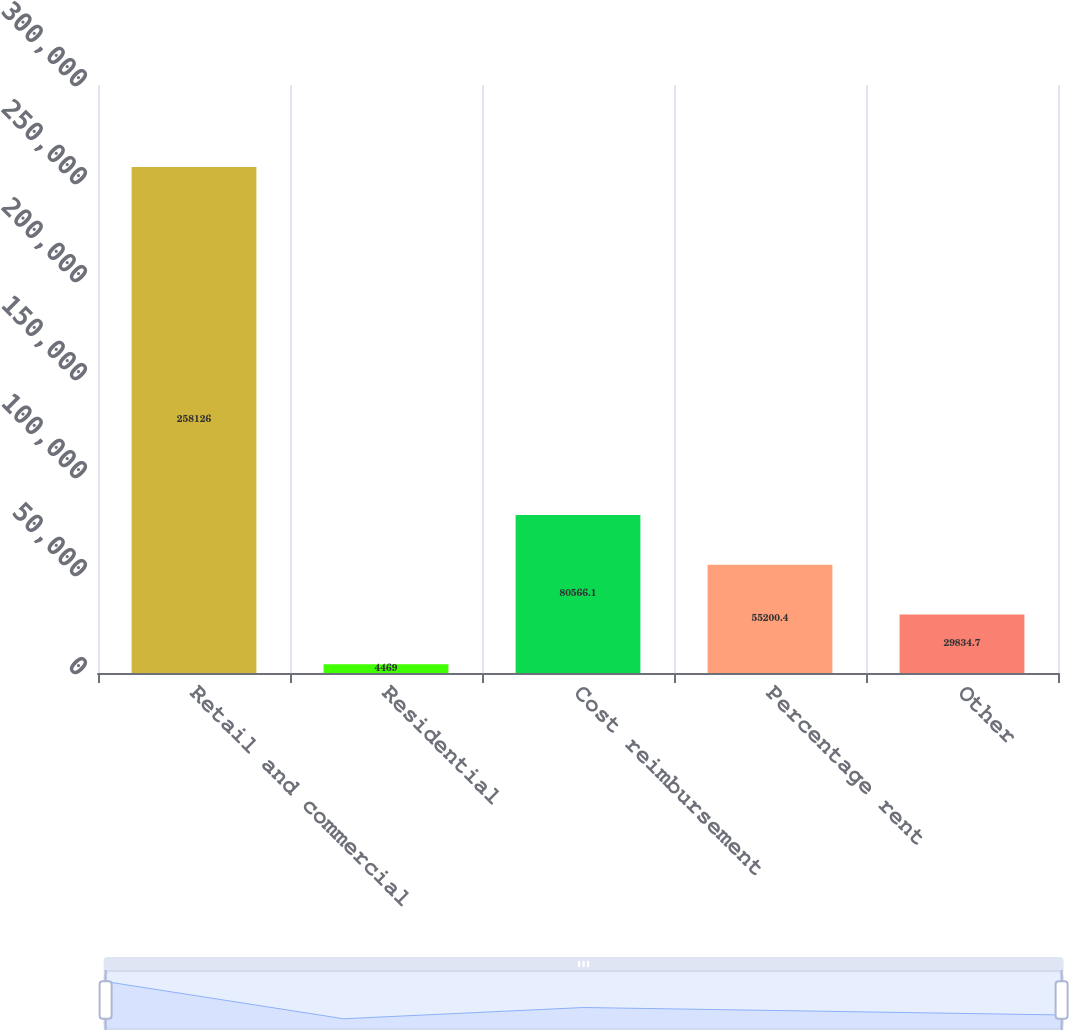<chart> <loc_0><loc_0><loc_500><loc_500><bar_chart><fcel>Retail and commercial<fcel>Residential<fcel>Cost reimbursement<fcel>Percentage rent<fcel>Other<nl><fcel>258126<fcel>4469<fcel>80566.1<fcel>55200.4<fcel>29834.7<nl></chart> 